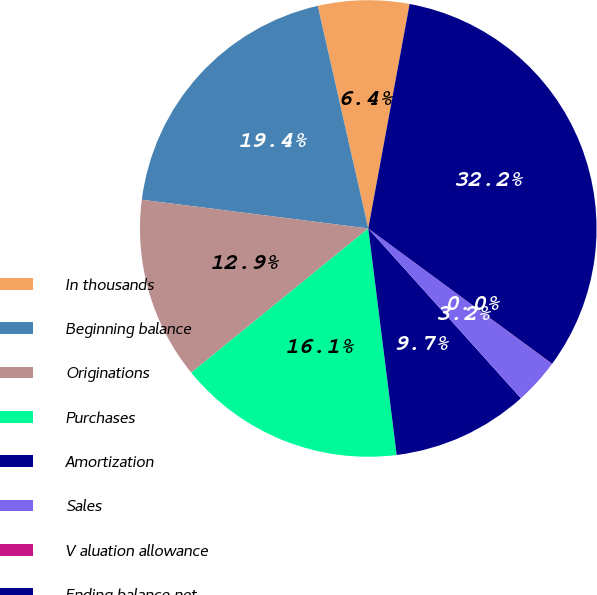<chart> <loc_0><loc_0><loc_500><loc_500><pie_chart><fcel>In thousands<fcel>Beginning balance<fcel>Originations<fcel>Purchases<fcel>Amortization<fcel>Sales<fcel>V aluation allowance<fcel>Ending balance net<nl><fcel>6.45%<fcel>19.44%<fcel>12.89%<fcel>16.11%<fcel>9.67%<fcel>3.23%<fcel>0.02%<fcel>32.2%<nl></chart> 